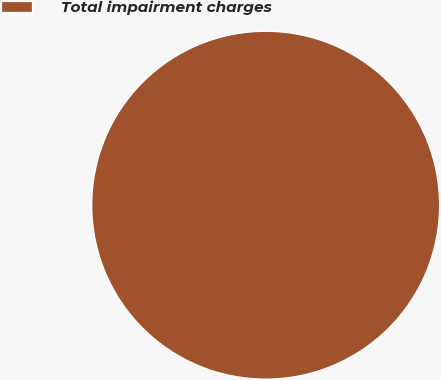Convert chart. <chart><loc_0><loc_0><loc_500><loc_500><pie_chart><fcel>Total impairment charges<nl><fcel>100.0%<nl></chart> 